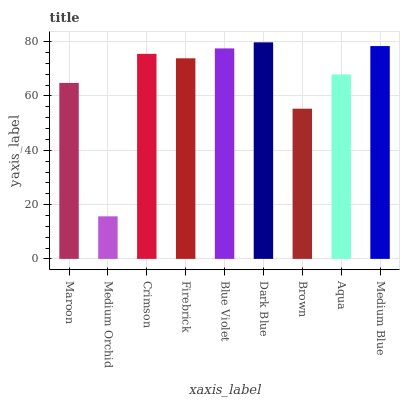Is Crimson the minimum?
Answer yes or no. No. Is Crimson the maximum?
Answer yes or no. No. Is Crimson greater than Medium Orchid?
Answer yes or no. Yes. Is Medium Orchid less than Crimson?
Answer yes or no. Yes. Is Medium Orchid greater than Crimson?
Answer yes or no. No. Is Crimson less than Medium Orchid?
Answer yes or no. No. Is Firebrick the high median?
Answer yes or no. Yes. Is Firebrick the low median?
Answer yes or no. Yes. Is Maroon the high median?
Answer yes or no. No. Is Medium Blue the low median?
Answer yes or no. No. 